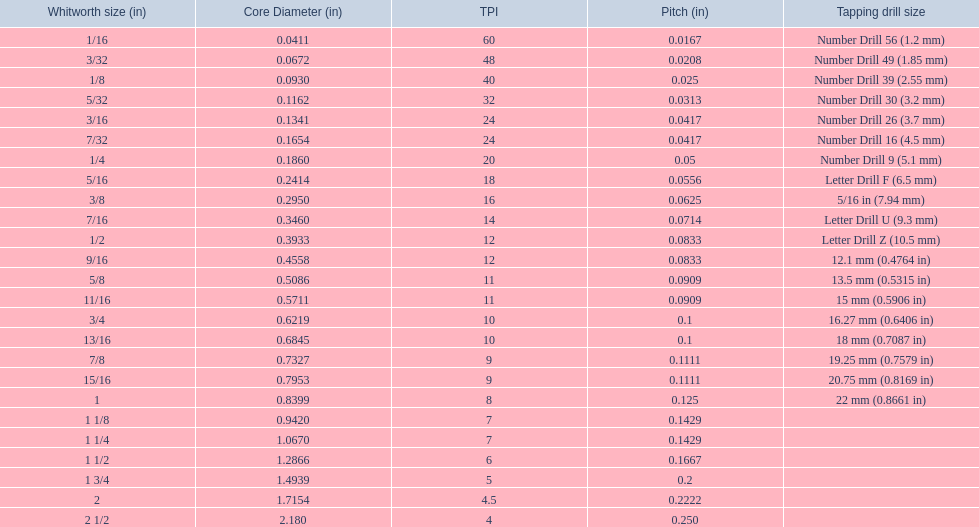What are all of the whitworth sizes? 1/16, 3/32, 1/8, 5/32, 3/16, 7/32, 1/4, 5/16, 3/8, 7/16, 1/2, 9/16, 5/8, 11/16, 3/4, 13/16, 7/8, 15/16, 1, 1 1/8, 1 1/4, 1 1/2, 1 3/4, 2, 2 1/2. How many threads per inch are in each size? 60, 48, 40, 32, 24, 24, 20, 18, 16, 14, 12, 12, 11, 11, 10, 10, 9, 9, 8, 7, 7, 6, 5, 4.5, 4. How many threads per inch are in the 3/16 size? 24. And which other size has the same number of threads? 7/32. 